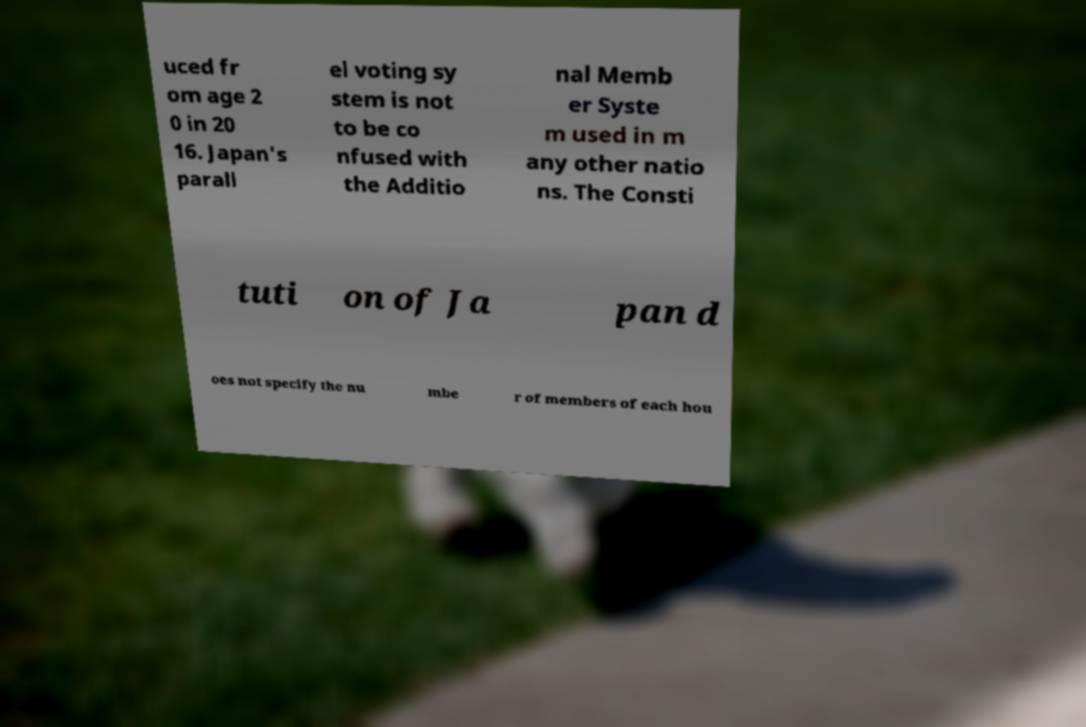I need the written content from this picture converted into text. Can you do that? uced fr om age 2 0 in 20 16. Japan's parall el voting sy stem is not to be co nfused with the Additio nal Memb er Syste m used in m any other natio ns. The Consti tuti on of Ja pan d oes not specify the nu mbe r of members of each hou 